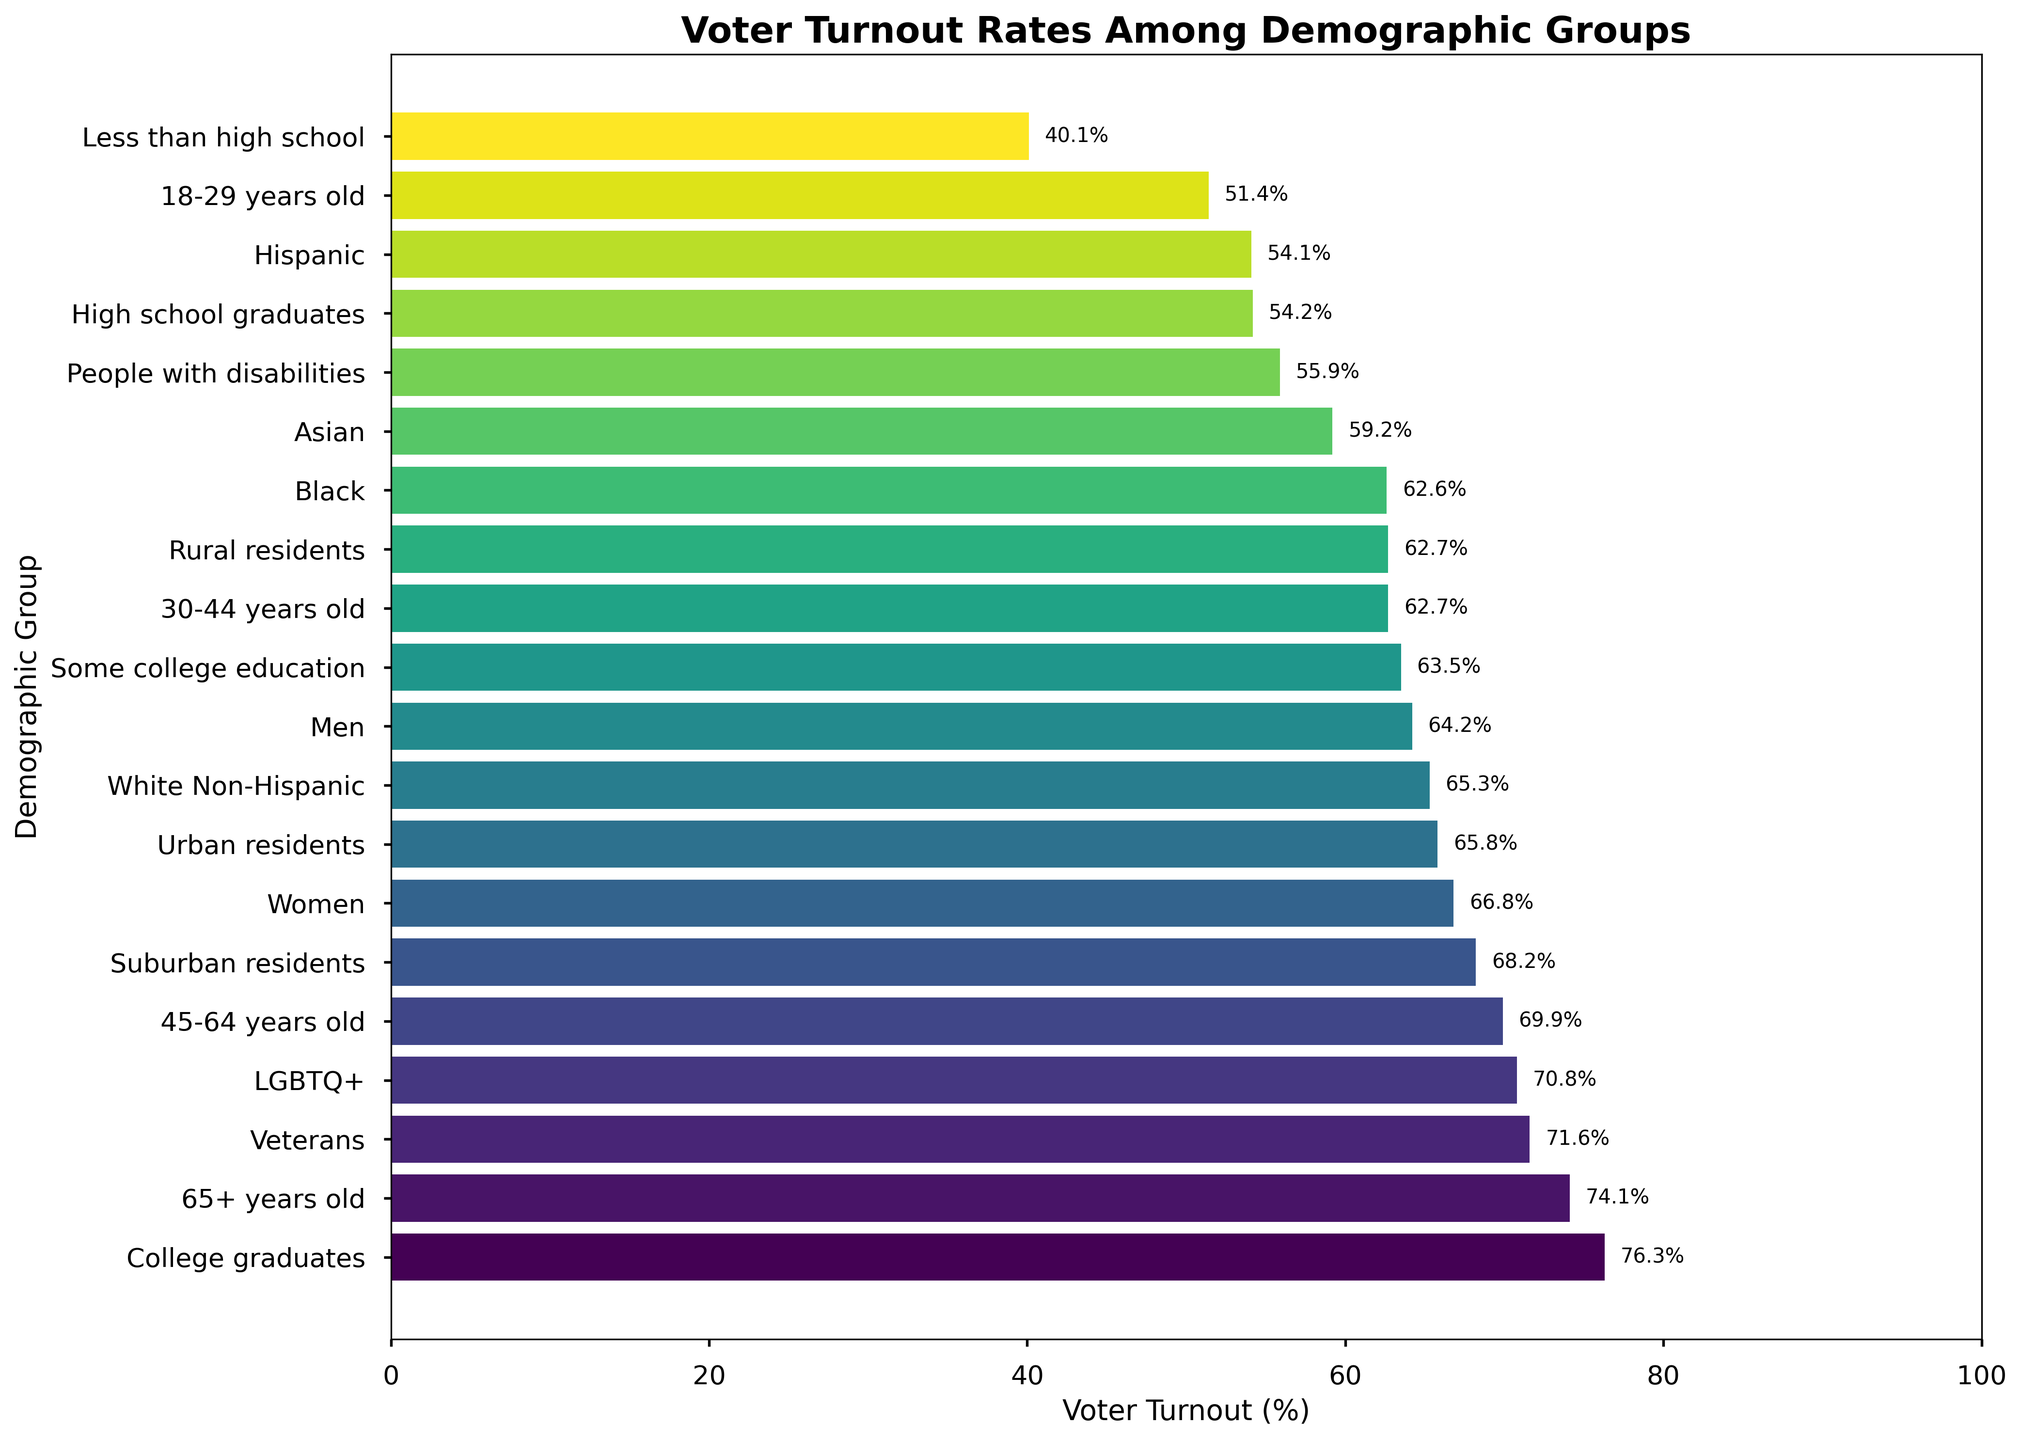Which demographic group has the highest voter turnout rate? According to the figure, the demographic group 'College Graduates' has the highest voter turnout rate with 76.3%.
Answer: College graduates What is the difference in voter turnout rates between 'Women' and 'Men'? The figure shows that 'Women' have a voter turnout rate of 66.8%, while 'Men' have a rate of 64.2%. The difference is calculated as 66.8% - 64.2% = 2.6%.
Answer: 2.6% Which demographic group has the lowest voter turnout rate? The figure indicates that the demographic group 'Less than high school' has the lowest voter turnout rate with 40.1%.
Answer: Less than high school What is the average voter turnout rate among the aged-based demographic groups ('18-29 years old', '30-44 years old', '45-64 years old', '65+ years old')? The voter turnout rates for these groups are 51.4%, 62.7%, 69.9%, and 74.1% respectively. The average is calculated as (51.4 + 62.7 + 69.9 + 74.1) / 4 = 64.525%.
Answer: 64.5% Are 'Urban residents' voter turnout rates higher or lower than 'Rural residents'? According to the figure, 'Urban residents' have a voter turnout rate of 65.8%, which is higher than 'Rural residents' who have 62.7%.
Answer: Higher What is the total voter turnout rate for 'White Non-Hispanic', 'Black', 'Hispanic', and 'Asian' groups combined? The voter turnout rates for these groups are 65.3%, 62.6%, 54.1%, and 59.2% respectively. The total is calculated as 65.3 + 62.6 + 54.1 + 59.2 = 241.2%.
Answer: 241.2% Among educational attainment groups (College graduates, Some college education, High school graduates, Less than high school), which group has the highest voter turnout rate? The figure shows that 'College graduates' have the highest voter turnout rate with 76.3%.
Answer: College graduates Which has a higher voter turnout rate: 'People with disabilities' or 'High school graduates'? The voter turnout rates are 55.9% for 'People with disabilities' and 54.2% for 'High school graduates'. Therefore, 'People with disabilities' have a higher turnout rate.
Answer: People with disabilities By how much do 'Veterans' voter turnout rates exceed the overall average voter turnout rate for all groups combined? First, calculate the average voter turnout rate for all groups. Sum of all rates: 1272.6% (sum of all percentages). There are 20 groups, so the average is 1272.6/20 = 63.63%. The turnout rate for 'Veterans' is 71.6%. The difference is 71.6% - 63.63% = 7.97%.
Answer: 7.97% 